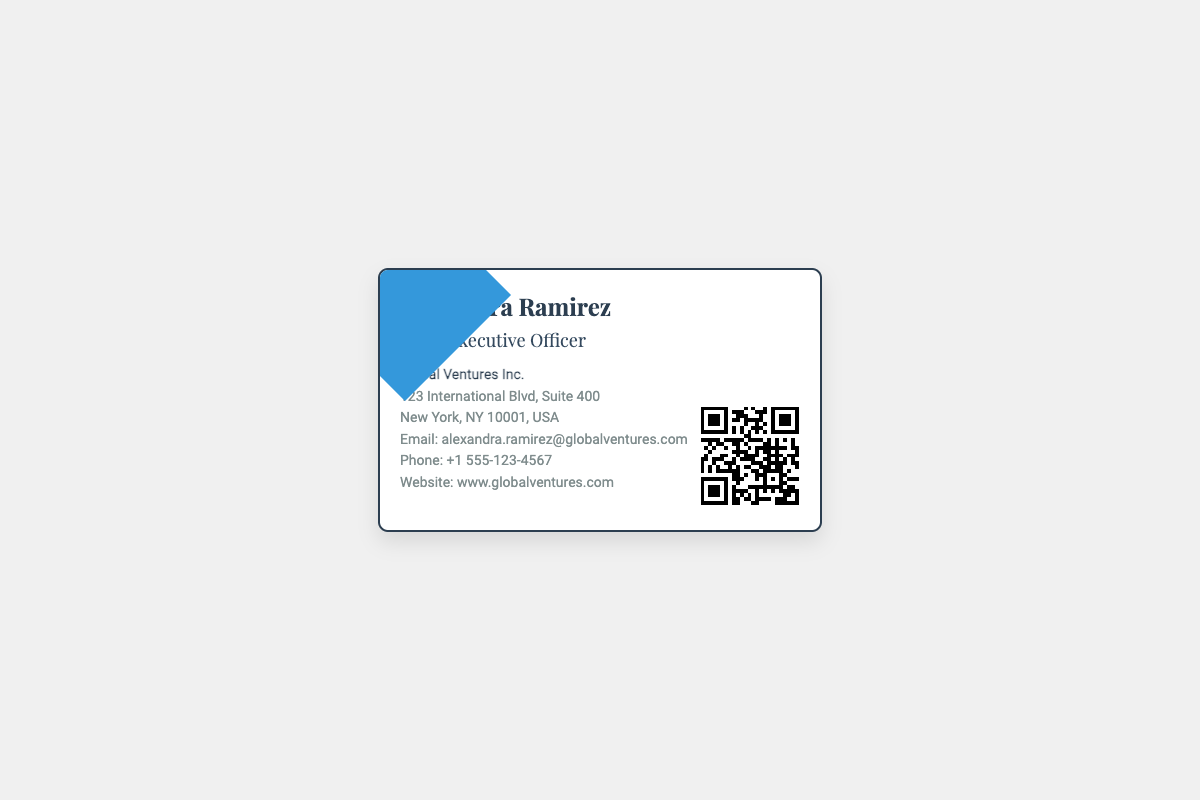What is the name on the business card? The name on the card is clearly displayed at the top of the document.
Answer: Alexandra Ramirez What is the title of Alexandra Ramirez? The title is found just below the name on the card.
Answer: Chief Executive Officer What is the name of the company? The company name is stated after the title in a bold format.
Answer: Global Ventures Inc What is the address of the company? The address is provided in a structured format, starting with the street number.
Answer: 123 International Blvd, Suite 400 What is Alexandra Ramirez's email address? The email is listed in the contact information section of the card.
Answer: alexandra.ramirez@globalventures.com What is the phone number listed on the business card? The phone number is included in the contact details section.
Answer: +1 555-123-4567 How can one visit the company website? The website link is provided in the contact information section and is accessible through the QR code.
Answer: www.globalventures.com What visual element is included on the card? The QR code serves as a visual element on the card for easy access to the website.
Answer: QR Code What color is the border of the business card? The color of the border is noted in the description of the design elements of the card.
Answer: Dark Blue What design feature is present behind the text on the card? A distinctive design element enhances the overall appearance and is noted in the document structure.
Answer: Diagonal Line 